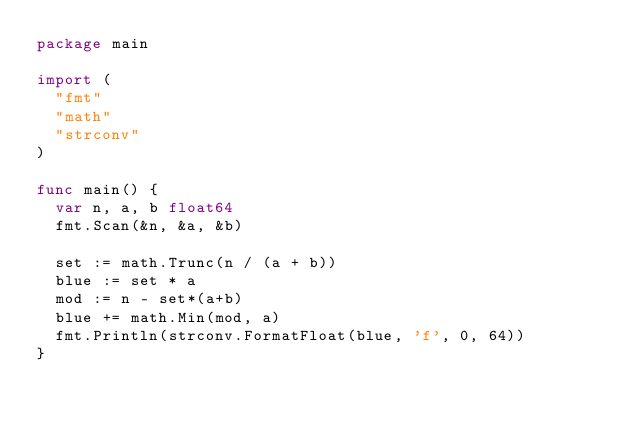Convert code to text. <code><loc_0><loc_0><loc_500><loc_500><_Go_>package main

import (
	"fmt"
	"math"
	"strconv"
)

func main() {
	var n, a, b float64
	fmt.Scan(&n, &a, &b)

	set := math.Trunc(n / (a + b))
	blue := set * a
	mod := n - set*(a+b)
	blue += math.Min(mod, a)
	fmt.Println(strconv.FormatFloat(blue, 'f', 0, 64))
}
</code> 